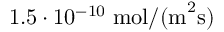<formula> <loc_0><loc_0><loc_500><loc_500>1 . 5 \cdot 1 0 ^ { - 1 0 } \, m o l / ( m ^ { 2 } s )</formula> 